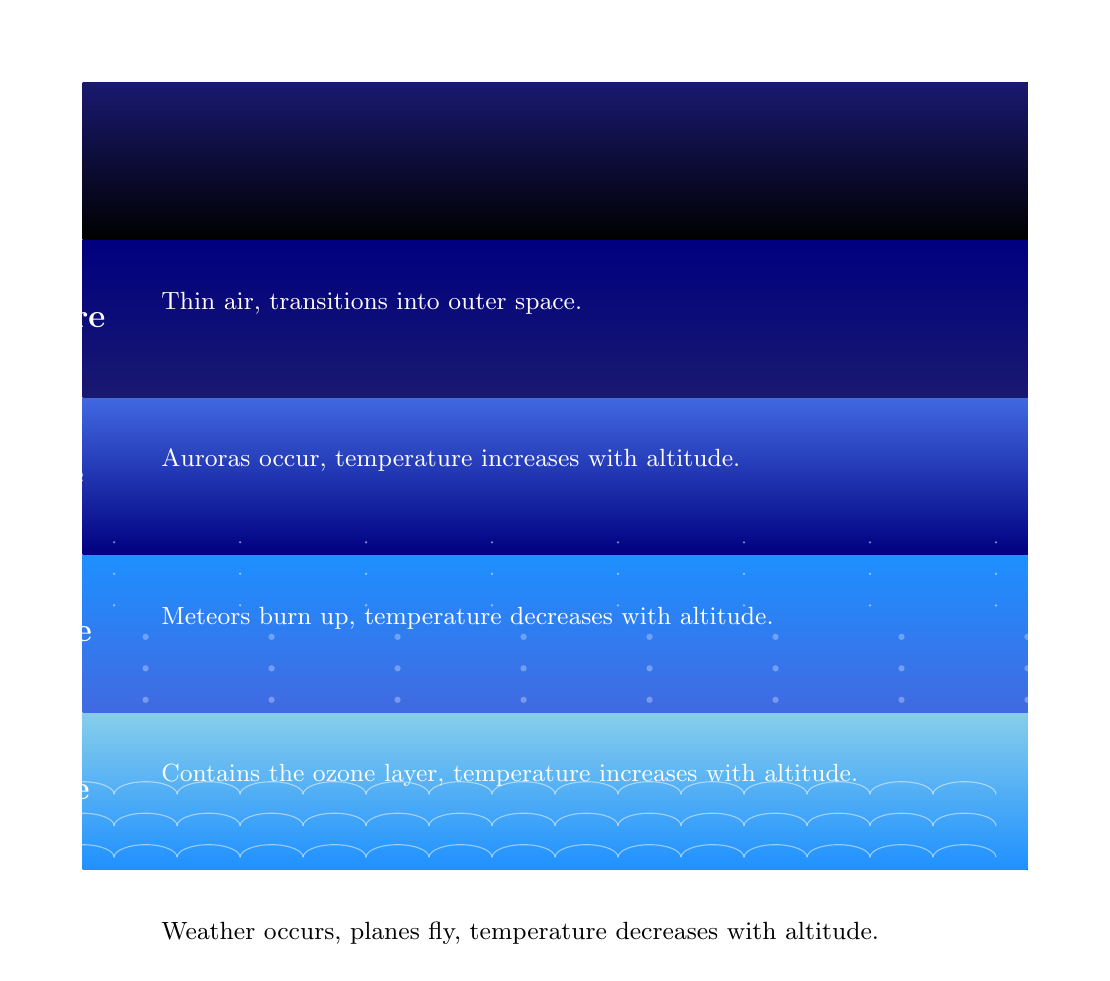What is the height range of the Stratosphere? The Stratosphere is indicated to be between 12-50 km, as specified in the text next to the corresponding color-coded section of the diagram.
Answer: 12-50 km What occurs in the Mesosphere? The section for the Mesosphere states that meteors burn up within this layer. This is explicitly mentioned in the description provided in the diagram.
Answer: Meteors burn up How many layers of the atmosphere are represented in the diagram? By counting the distinct sections in the diagram, there are a total of five layers indicated: Troposphere, Stratosphere, Mesosphere, Thermosphere, and Exosphere.
Answer: Five Which atmospheric layer experiences increasing temperature with altitude? The Stratosphere is highlighted in the description as the layer where temperature increases with altitude, making it the correct answer based on the information provided.
Answer: Stratosphere What is the characteristic of the Exosphere as depicted in the diagram? The description provided for the Exosphere mentions "Thin air, transitions into outer space," which accurately represents its defining characteristic as illustrated in the diagram.
Answer: Thin air, transitions into outer space What is the highest layer of the atmosphere shown? The Exosphere is depicted at the top of the diagram, indicating it is the highest layer among the atmospheric sections represented.
Answer: Exosphere Which atmospheric layer is associated with auroras? The Thermosphere is noted for where auroras occur, based on the descriptive text adjacent to the corresponding section of the diagram, thus making it the correct answer.
Answer: Thermosphere What color represents the Troposphere in the diagram? The Troposphere is represented by a shade of light blue (HTML color 87CEEB) depicted in the first section of the diagram, which is visible and clearly identified as the color associated with this layer.
Answer: Light blue 